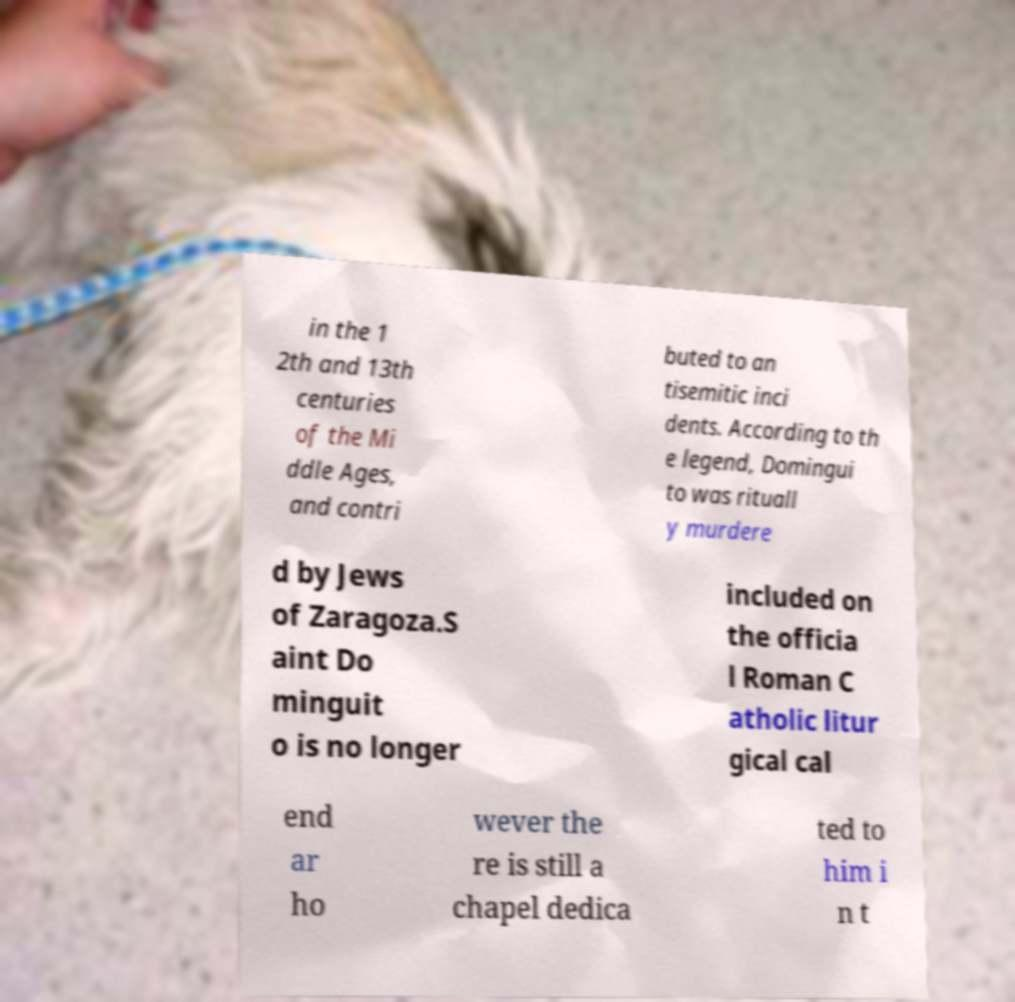Please identify and transcribe the text found in this image. in the 1 2th and 13th centuries of the Mi ddle Ages, and contri buted to an tisemitic inci dents. According to th e legend, Domingui to was rituall y murdere d by Jews of Zaragoza.S aint Do minguit o is no longer included on the officia l Roman C atholic litur gical cal end ar ho wever the re is still a chapel dedica ted to him i n t 